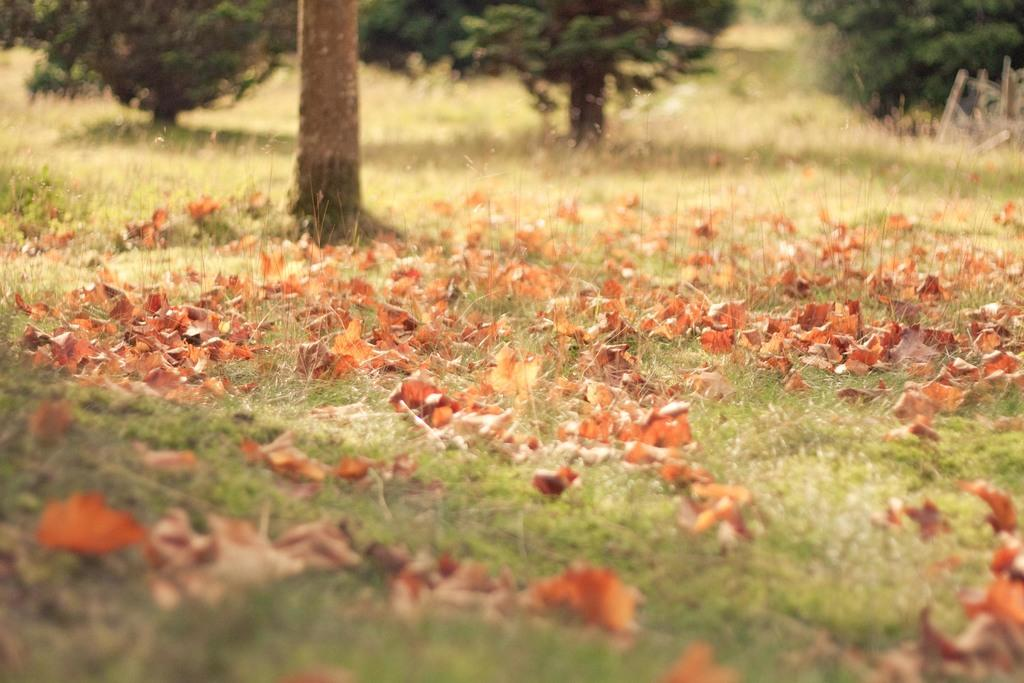What type of vegetation is present at the bottom of the image? There is grass and dry leaves on the ground at the bottom of the image. What can be seen in the background of the image? There are trees and a tree trunk in the background of the image. How many tree trunks are visible in the background of the image? There are two tree trunks visible in the background of the image. Can you hear the rat laughing in the image? There is no rat or laughter present in the image. Is there a cub playing with the tree trunk in the image? There is no cub or any indication of an animal playing with the tree trunk in the image. 